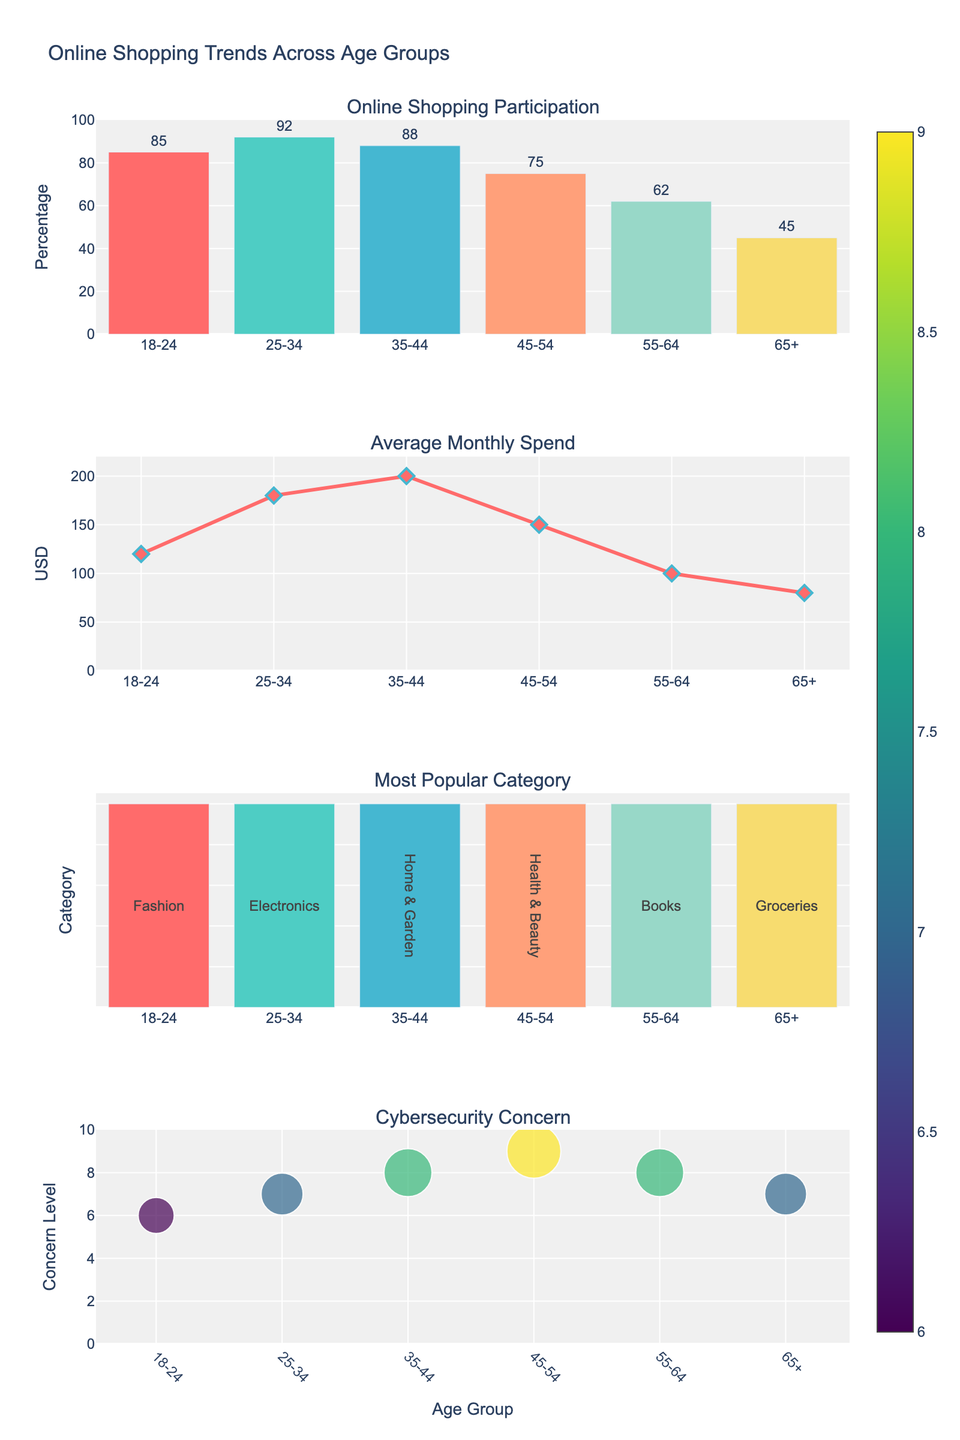What is the title of the figure? The title of the figure is usually located at the top center and provides a summary of what the figure represents.
Answer: Maillard Reaction Intensity in Various Baked Goods How many distinct baked goods are represented in the subplots? Each subplot title represents a different baked good. Counting the titles will give the number of distinct baked goods.
Answer: Five Which baked good shows the highest Maillard reaction intensity at 250°C? Look at the individual subplots and compare the values at 250°C for each baked good.
Answer: Cookies What is the range of temperatures shown on the x-axis? Check the x-axis labeling from the lowest to the highest value.
Answer: 140°C to 260°C How does the Maillard reaction intensity of Croissants at 175°C compare to that of Pie Crust? Locate the points for Croissants and Pie Crust at 175°C and compare their y-axis values.
Answer: Croissants have higher intensity than Pie Crust Which baked good has the steepest increase in Maillard reaction intensity between 200°C and 225°C? Calculate the difference in Maillard reaction intensity between 200°C and 225°C for each baked good and compare them.
Answer: Pie Crust What is the Maillard reaction intensity value for Pizza Crust at 200°C? Locate the subplot for Pizza Crust and read the y-axis value at 200°C.
Answer: 48 At which temperature does Bread start to show a significant increase in Maillard reaction intensity? Observe the Bread subplot and identify the temperature at which the intensity starts to rise sharply.
Answer: 175°C Calculate the average Maillard reaction intensity for Cookies across all temperatures. Sum the Maillard reaction intensity values for Cookies at all temperatures and divide by the number of temperatures. (15+30+50+75+95)/5 = 53
Answer: 53 How do the Maillard reaction intensities for Bread and Pizza Crust at 225°C compare? Locate the points on their respective subplots and compare the y-axis values for Bread and Pizza Crust at 225°C.
Answer: Bread has slightly lower intensity than Pizza Crust 